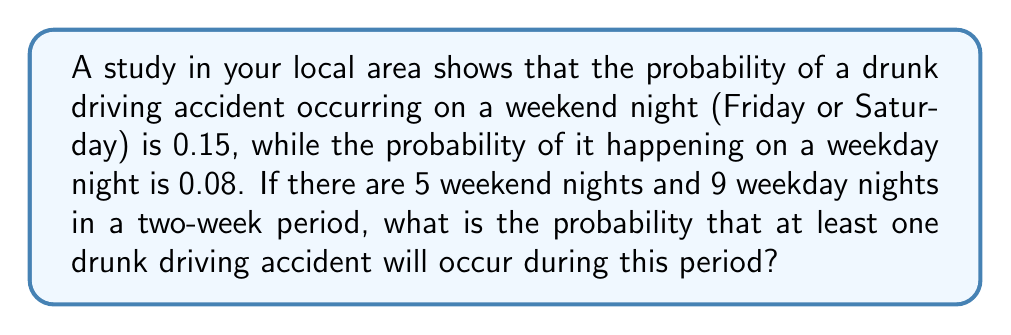Could you help me with this problem? Let's approach this step-by-step:

1) First, let's calculate the probability of no accident occurring on a single weekend night:
   $P(\text{no accident on weekend night}) = 1 - 0.15 = 0.85$

2) For weekday nights:
   $P(\text{no accident on weekday night}) = 1 - 0.08 = 0.92$

3) Now, for no accidents to occur during the entire two-week period, we need no accidents on all 5 weekend nights AND all 9 weekday nights. The probability of this is:

   $P(\text{no accidents in two weeks}) = (0.85)^5 \times (0.92)^9$

4) Let's calculate this:
   $$(0.85)^5 \times (0.92)^9 = 0.4437 \times 0.4670 = 0.2072$$

5) Therefore, the probability of at least one accident occurring is the complement of this probability:

   $P(\text{at least one accident}) = 1 - P(\text{no accidents})$
   $= 1 - 0.2072 = 0.7928$

6) Converting to a percentage:
   $0.7928 \times 100\% = 79.28\%$
Answer: The probability that at least one drunk driving accident will occur during the two-week period is approximately $79.28\%$. 